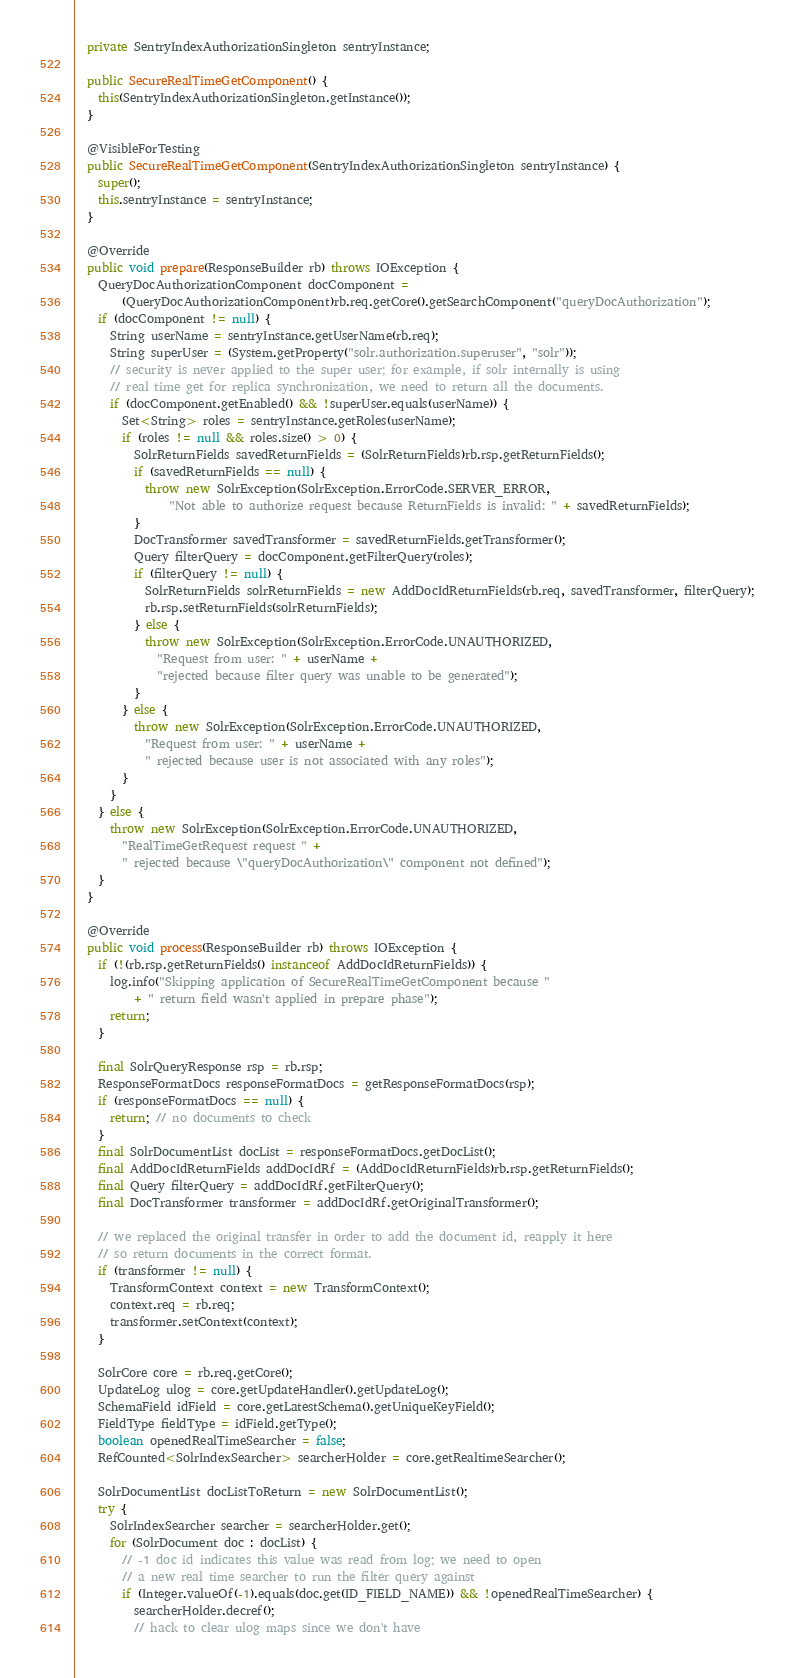<code> <loc_0><loc_0><loc_500><loc_500><_Java_>
  private SentryIndexAuthorizationSingleton sentryInstance;

  public SecureRealTimeGetComponent() {
    this(SentryIndexAuthorizationSingleton.getInstance());
  }

  @VisibleForTesting
  public SecureRealTimeGetComponent(SentryIndexAuthorizationSingleton sentryInstance) {
    super();
    this.sentryInstance = sentryInstance;
  }

  @Override
  public void prepare(ResponseBuilder rb) throws IOException {
    QueryDocAuthorizationComponent docComponent =
        (QueryDocAuthorizationComponent)rb.req.getCore().getSearchComponent("queryDocAuthorization");
    if (docComponent != null) {
      String userName = sentryInstance.getUserName(rb.req);
      String superUser = (System.getProperty("solr.authorization.superuser", "solr"));
      // security is never applied to the super user; for example, if solr internally is using
      // real time get for replica synchronization, we need to return all the documents.
      if (docComponent.getEnabled() && !superUser.equals(userName)) {
        Set<String> roles = sentryInstance.getRoles(userName);
        if (roles != null && roles.size() > 0) {
          SolrReturnFields savedReturnFields = (SolrReturnFields)rb.rsp.getReturnFields();
          if (savedReturnFields == null) {
            throw new SolrException(SolrException.ErrorCode.SERVER_ERROR,
                "Not able to authorize request because ReturnFields is invalid: " + savedReturnFields);
          }
          DocTransformer savedTransformer = savedReturnFields.getTransformer();
          Query filterQuery = docComponent.getFilterQuery(roles);
          if (filterQuery != null) {
            SolrReturnFields solrReturnFields = new AddDocIdReturnFields(rb.req, savedTransformer, filterQuery);
            rb.rsp.setReturnFields(solrReturnFields);
          } else {
            throw new SolrException(SolrException.ErrorCode.UNAUTHORIZED,
              "Request from user: " + userName +
              "rejected because filter query was unable to be generated");
          }
        } else {
          throw new SolrException(SolrException.ErrorCode.UNAUTHORIZED,
            "Request from user: " + userName +
            " rejected because user is not associated with any roles");
        }
      }
    } else {
      throw new SolrException(SolrException.ErrorCode.UNAUTHORIZED,
        "RealTimeGetRequest request " +
        " rejected because \"queryDocAuthorization\" component not defined");
    }
  }

  @Override
  public void process(ResponseBuilder rb) throws IOException {
    if (!(rb.rsp.getReturnFields() instanceof AddDocIdReturnFields)) {
      log.info("Skipping application of SecureRealTimeGetComponent because "
          + " return field wasn't applied in prepare phase");
      return;
    }

    final SolrQueryResponse rsp = rb.rsp;
    ResponseFormatDocs responseFormatDocs = getResponseFormatDocs(rsp);
    if (responseFormatDocs == null) {
      return; // no documents to check
    }
    final SolrDocumentList docList = responseFormatDocs.getDocList();
    final AddDocIdReturnFields addDocIdRf = (AddDocIdReturnFields)rb.rsp.getReturnFields();
    final Query filterQuery = addDocIdRf.getFilterQuery();
    final DocTransformer transformer = addDocIdRf.getOriginalTransformer();

    // we replaced the original transfer in order to add the document id, reapply it here
    // so return documents in the correct format.
    if (transformer != null) {
      TransformContext context = new TransformContext();
      context.req = rb.req;
      transformer.setContext(context);
    }

    SolrCore core = rb.req.getCore();
    UpdateLog ulog = core.getUpdateHandler().getUpdateLog();
    SchemaField idField = core.getLatestSchema().getUniqueKeyField();
    FieldType fieldType = idField.getType();
    boolean openedRealTimeSearcher = false;
    RefCounted<SolrIndexSearcher> searcherHolder = core.getRealtimeSearcher();

    SolrDocumentList docListToReturn = new SolrDocumentList();
    try {
      SolrIndexSearcher searcher = searcherHolder.get();
      for (SolrDocument doc : docList) {
        // -1 doc id indicates this value was read from log; we need to open
        // a new real time searcher to run the filter query against
        if (Integer.valueOf(-1).equals(doc.get(ID_FIELD_NAME)) && !openedRealTimeSearcher) {
          searcherHolder.decref();
          // hack to clear ulog maps since we don't have</code> 